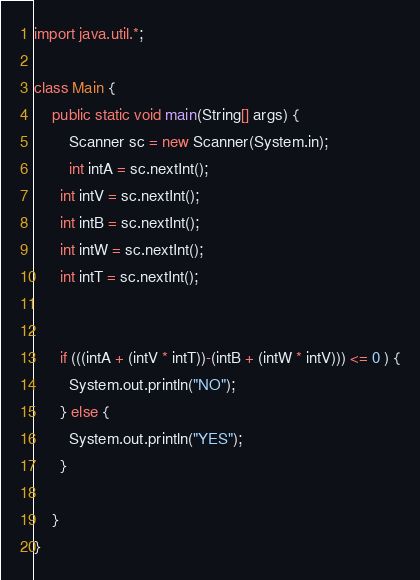Convert code to text. <code><loc_0><loc_0><loc_500><loc_500><_Java_>import java.util.*;
 
class Main {
    public static void main(String[] args) {
        Scanner sc = new Scanner(System.in);
		int intA = sc.nextInt();
      int intV = sc.nextInt();
      int intB = sc.nextInt();
      int intW = sc.nextInt();
      int intT = sc.nextInt();
      

      if (((intA + (intV * intT))-(intB + (intW * intV))) <= 0 ) {
        System.out.println("NO");
      } else {
        System.out.println("YES");
      }
 
    }
}

</code> 